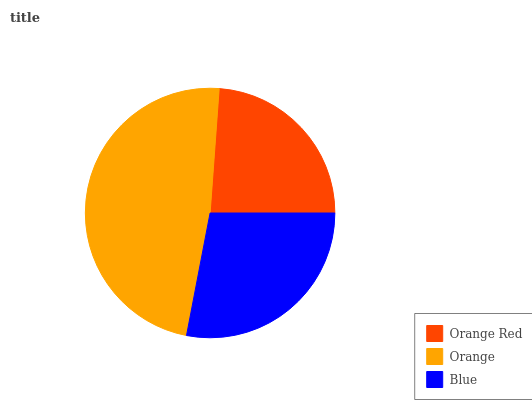Is Orange Red the minimum?
Answer yes or no. Yes. Is Orange the maximum?
Answer yes or no. Yes. Is Blue the minimum?
Answer yes or no. No. Is Blue the maximum?
Answer yes or no. No. Is Orange greater than Blue?
Answer yes or no. Yes. Is Blue less than Orange?
Answer yes or no. Yes. Is Blue greater than Orange?
Answer yes or no. No. Is Orange less than Blue?
Answer yes or no. No. Is Blue the high median?
Answer yes or no. Yes. Is Blue the low median?
Answer yes or no. Yes. Is Orange the high median?
Answer yes or no. No. Is Orange the low median?
Answer yes or no. No. 